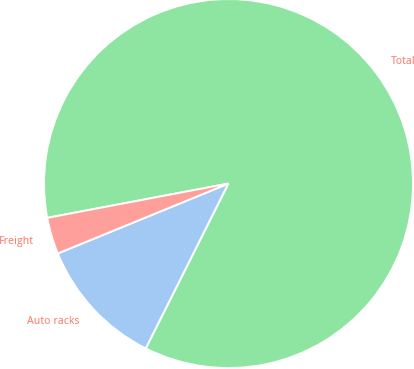Convert chart. <chart><loc_0><loc_0><loc_500><loc_500><pie_chart><fcel>Auto racks<fcel>Total<fcel>Freight<nl><fcel>11.42%<fcel>85.37%<fcel>3.21%<nl></chart> 